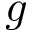<formula> <loc_0><loc_0><loc_500><loc_500>g</formula> 